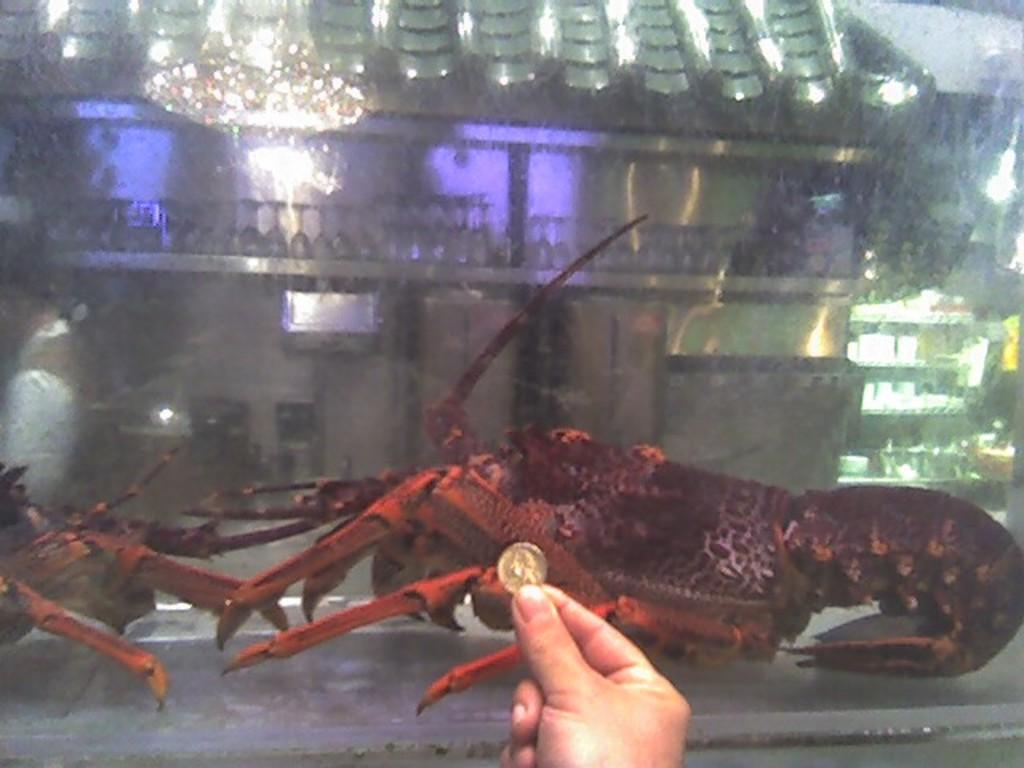What is the main subject of the image? There is a lobster in a mirror box in the image. What can be seen in the background of the image? There are wine glasses, a chandelier, cupboards, and a human hand visible in the background of the image. What is the time of day in the image? The time of day cannot be determined from the image, as there are no clues or indicators of the time. 